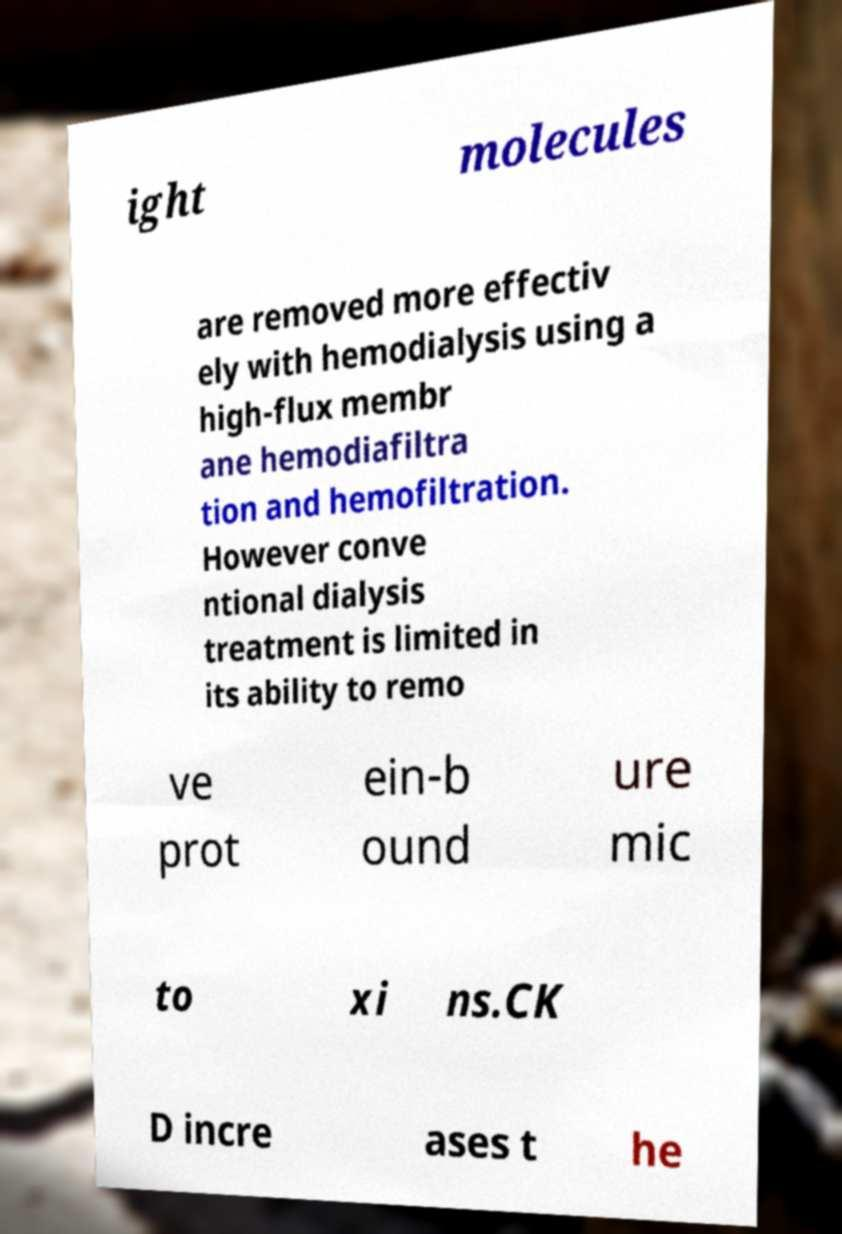Please identify and transcribe the text found in this image. ight molecules are removed more effectiv ely with hemodialysis using a high-flux membr ane hemodiafiltra tion and hemofiltration. However conve ntional dialysis treatment is limited in its ability to remo ve prot ein-b ound ure mic to xi ns.CK D incre ases t he 